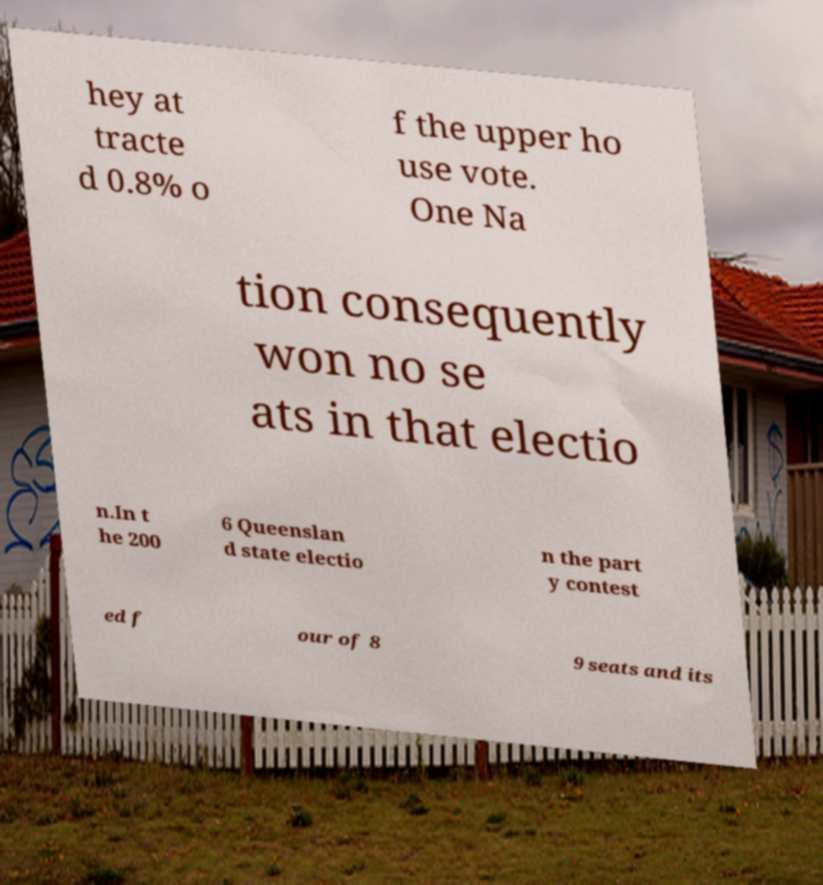Could you assist in decoding the text presented in this image and type it out clearly? hey at tracte d 0.8% o f the upper ho use vote. One Na tion consequently won no se ats in that electio n.In t he 200 6 Queenslan d state electio n the part y contest ed f our of 8 9 seats and its 